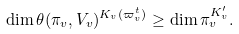<formula> <loc_0><loc_0><loc_500><loc_500>\dim \theta ( \pi _ { v } , V _ { v } ) ^ { K _ { v } ( \varpi _ { v } ^ { t } ) } \geq \dim \pi _ { v } ^ { K ^ { \prime } _ { v } } .</formula> 